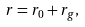<formula> <loc_0><loc_0><loc_500><loc_500>r = r _ { 0 } + r _ { g } ,</formula> 